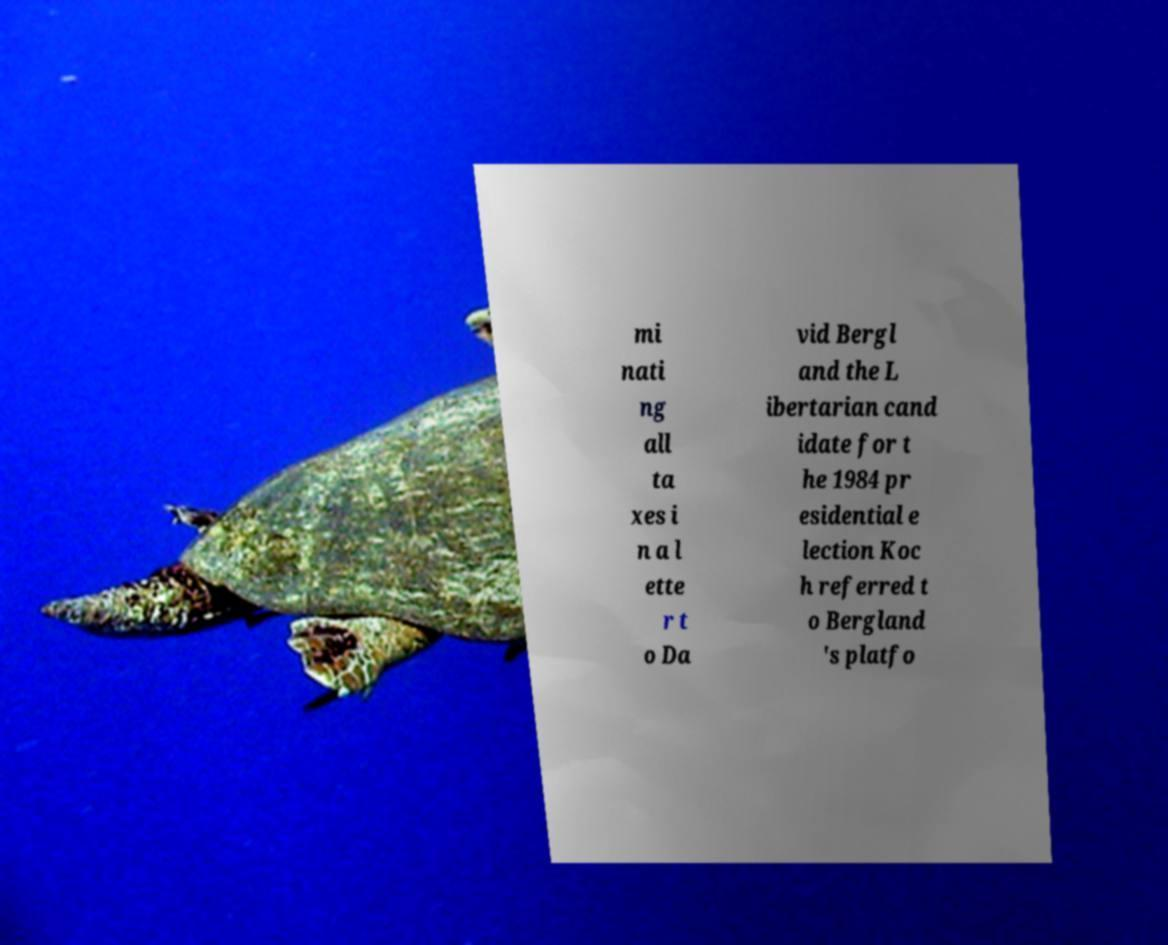Can you read and provide the text displayed in the image?This photo seems to have some interesting text. Can you extract and type it out for me? mi nati ng all ta xes i n a l ette r t o Da vid Bergl and the L ibertarian cand idate for t he 1984 pr esidential e lection Koc h referred t o Bergland 's platfo 